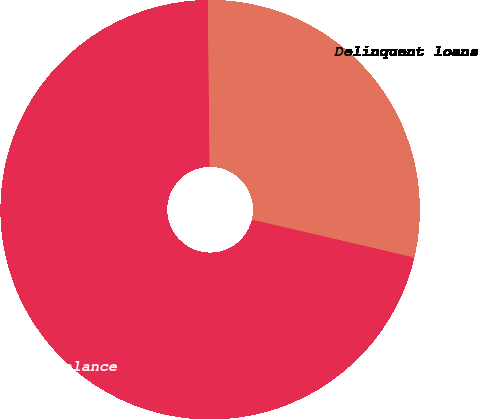<chart> <loc_0><loc_0><loc_500><loc_500><pie_chart><fcel>Total principal balance<fcel>Delinquent loans<nl><fcel>71.18%<fcel>28.82%<nl></chart> 